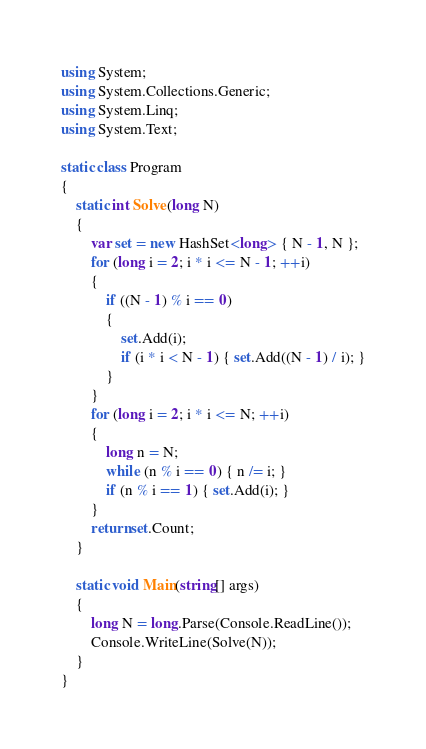Convert code to text. <code><loc_0><loc_0><loc_500><loc_500><_C#_>using System;
using System.Collections.Generic;
using System.Linq;
using System.Text;

static class Program
{
    static int Solve(long N)
    {
        var set = new HashSet<long> { N - 1, N };
        for (long i = 2; i * i <= N - 1; ++i)
        {
            if ((N - 1) % i == 0)
            {
                set.Add(i);
                if (i * i < N - 1) { set.Add((N - 1) / i); }
            }
        }
        for (long i = 2; i * i <= N; ++i)
        {
            long n = N;
            while (n % i == 0) { n /= i; }
            if (n % i == 1) { set.Add(i); }
        }
        return set.Count;
    }

    static void Main(string[] args)
    {
        long N = long.Parse(Console.ReadLine());
        Console.WriteLine(Solve(N));
    }
}
</code> 